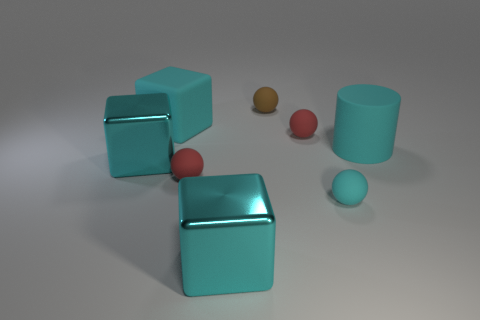Are there fewer big metal objects that are on the right side of the large matte cylinder than metal objects?
Provide a succinct answer. Yes. There is a large cyan rubber cube; what number of brown matte spheres are left of it?
Your answer should be very brief. 0. Does the small red object that is left of the brown thing have the same shape as the big cyan shiny thing on the right side of the cyan rubber cube?
Give a very brief answer. No. There is a cyan rubber object that is both left of the matte cylinder and behind the cyan matte sphere; what is its shape?
Give a very brief answer. Cube. There is a cyan cube that is made of the same material as the big cylinder; what is its size?
Provide a short and direct response. Large. Is the number of brown rubber objects less than the number of big yellow matte cubes?
Your answer should be compact. No. There is a cyan cube in front of the small matte thing left of the big cyan thing in front of the small cyan thing; what is it made of?
Offer a terse response. Metal. Do the large cyan thing that is in front of the small cyan rubber sphere and the big thing on the left side of the rubber cube have the same material?
Give a very brief answer. Yes. There is a matte thing that is in front of the cyan rubber cylinder and to the left of the cyan sphere; what is its size?
Your answer should be compact. Small. There is a cyan ball that is the same size as the brown object; what material is it?
Make the answer very short. Rubber. 